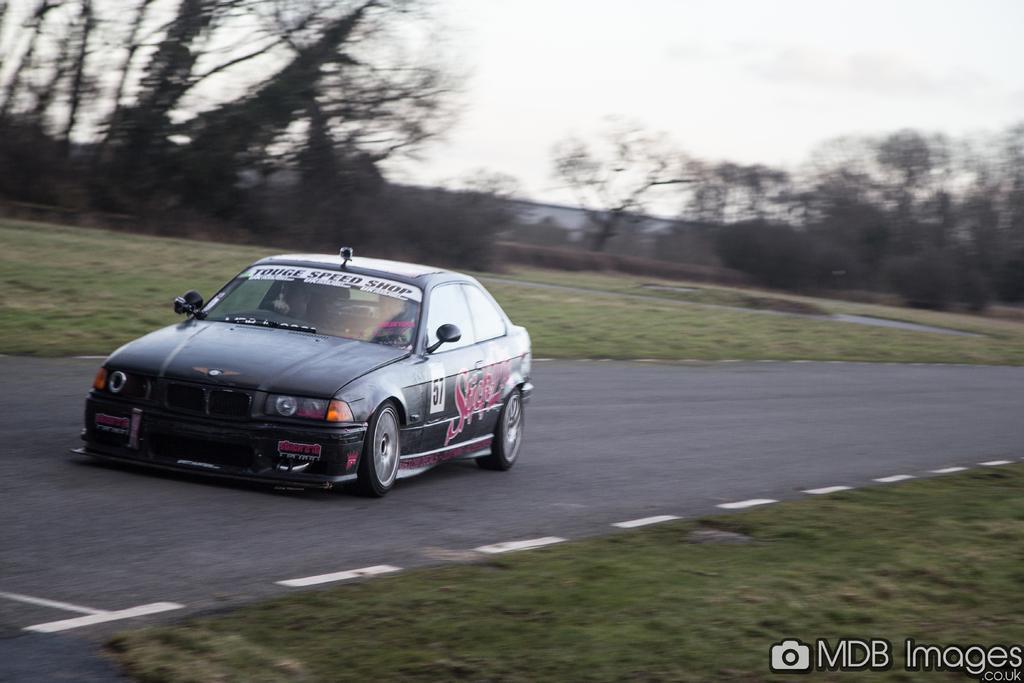Please provide a concise description of this image. The image is taken outside a city. In the foreground of the picture there is grass and a car on the road. The background is blurred. In the background there are trees, shrubs and building. It is cloudy. 